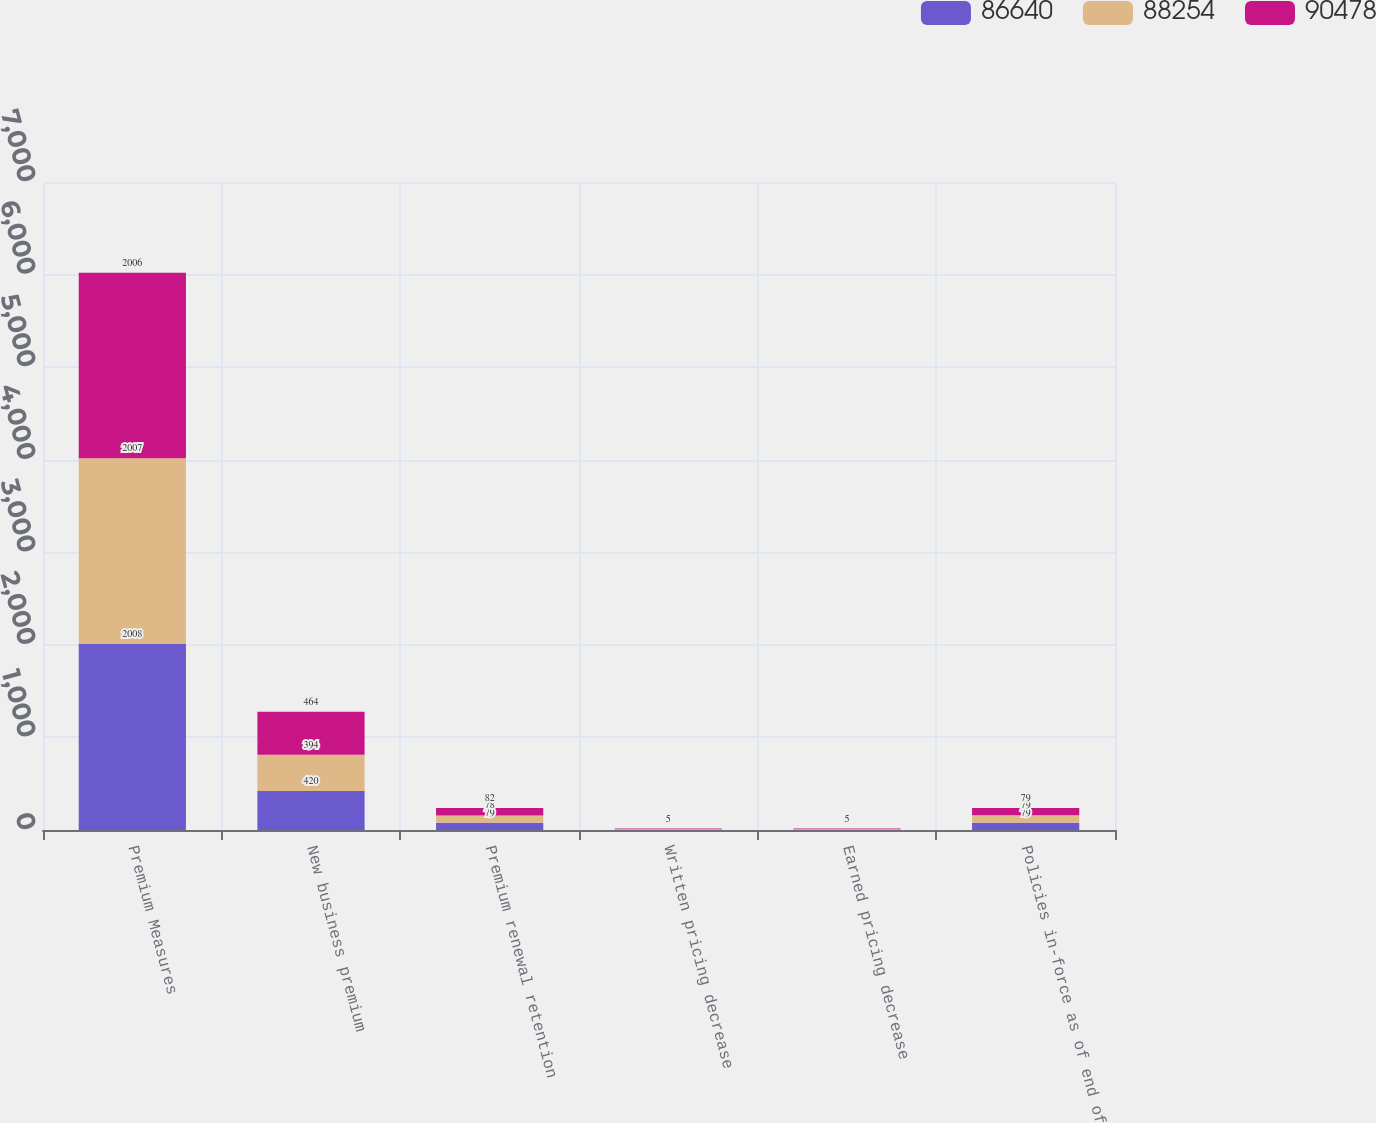Convert chart. <chart><loc_0><loc_0><loc_500><loc_500><stacked_bar_chart><ecel><fcel>Premium Measures<fcel>New business premium<fcel>Premium renewal retention<fcel>Written pricing decrease<fcel>Earned pricing decrease<fcel>Policies in-force as of end of<nl><fcel>86640<fcel>2008<fcel>420<fcel>79<fcel>5<fcel>6<fcel>79<nl><fcel>88254<fcel>2007<fcel>394<fcel>78<fcel>5<fcel>5<fcel>79<nl><fcel>90478<fcel>2006<fcel>464<fcel>82<fcel>5<fcel>5<fcel>79<nl></chart> 